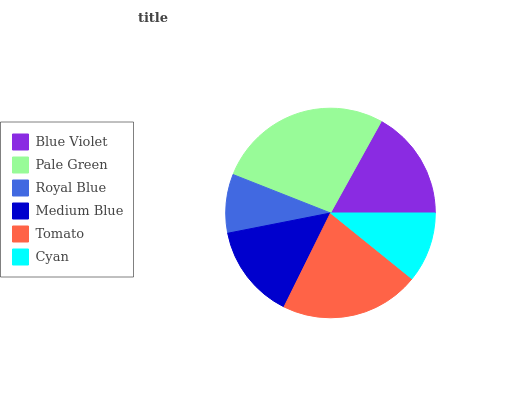Is Royal Blue the minimum?
Answer yes or no. Yes. Is Pale Green the maximum?
Answer yes or no. Yes. Is Pale Green the minimum?
Answer yes or no. No. Is Royal Blue the maximum?
Answer yes or no. No. Is Pale Green greater than Royal Blue?
Answer yes or no. Yes. Is Royal Blue less than Pale Green?
Answer yes or no. Yes. Is Royal Blue greater than Pale Green?
Answer yes or no. No. Is Pale Green less than Royal Blue?
Answer yes or no. No. Is Blue Violet the high median?
Answer yes or no. Yes. Is Medium Blue the low median?
Answer yes or no. Yes. Is Royal Blue the high median?
Answer yes or no. No. Is Tomato the low median?
Answer yes or no. No. 